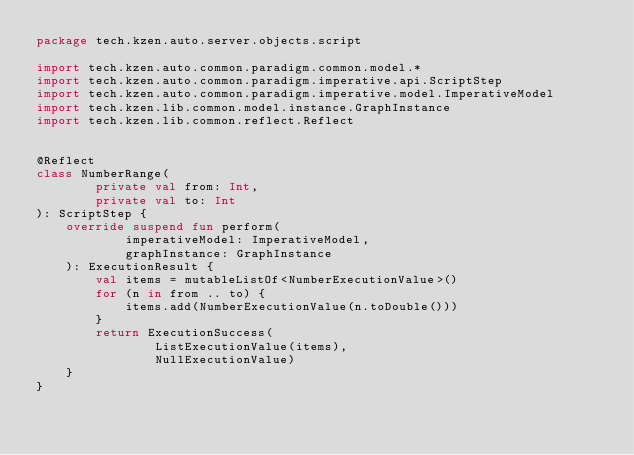<code> <loc_0><loc_0><loc_500><loc_500><_Kotlin_>package tech.kzen.auto.server.objects.script

import tech.kzen.auto.common.paradigm.common.model.*
import tech.kzen.auto.common.paradigm.imperative.api.ScriptStep
import tech.kzen.auto.common.paradigm.imperative.model.ImperativeModel
import tech.kzen.lib.common.model.instance.GraphInstance
import tech.kzen.lib.common.reflect.Reflect


@Reflect
class NumberRange(
        private val from: Int,
        private val to: Int
): ScriptStep {
    override suspend fun perform(
            imperativeModel: ImperativeModel,
            graphInstance: GraphInstance
    ): ExecutionResult {
        val items = mutableListOf<NumberExecutionValue>()
        for (n in from .. to) {
            items.add(NumberExecutionValue(n.toDouble()))
        }
        return ExecutionSuccess(
                ListExecutionValue(items),
                NullExecutionValue)
    }
}</code> 